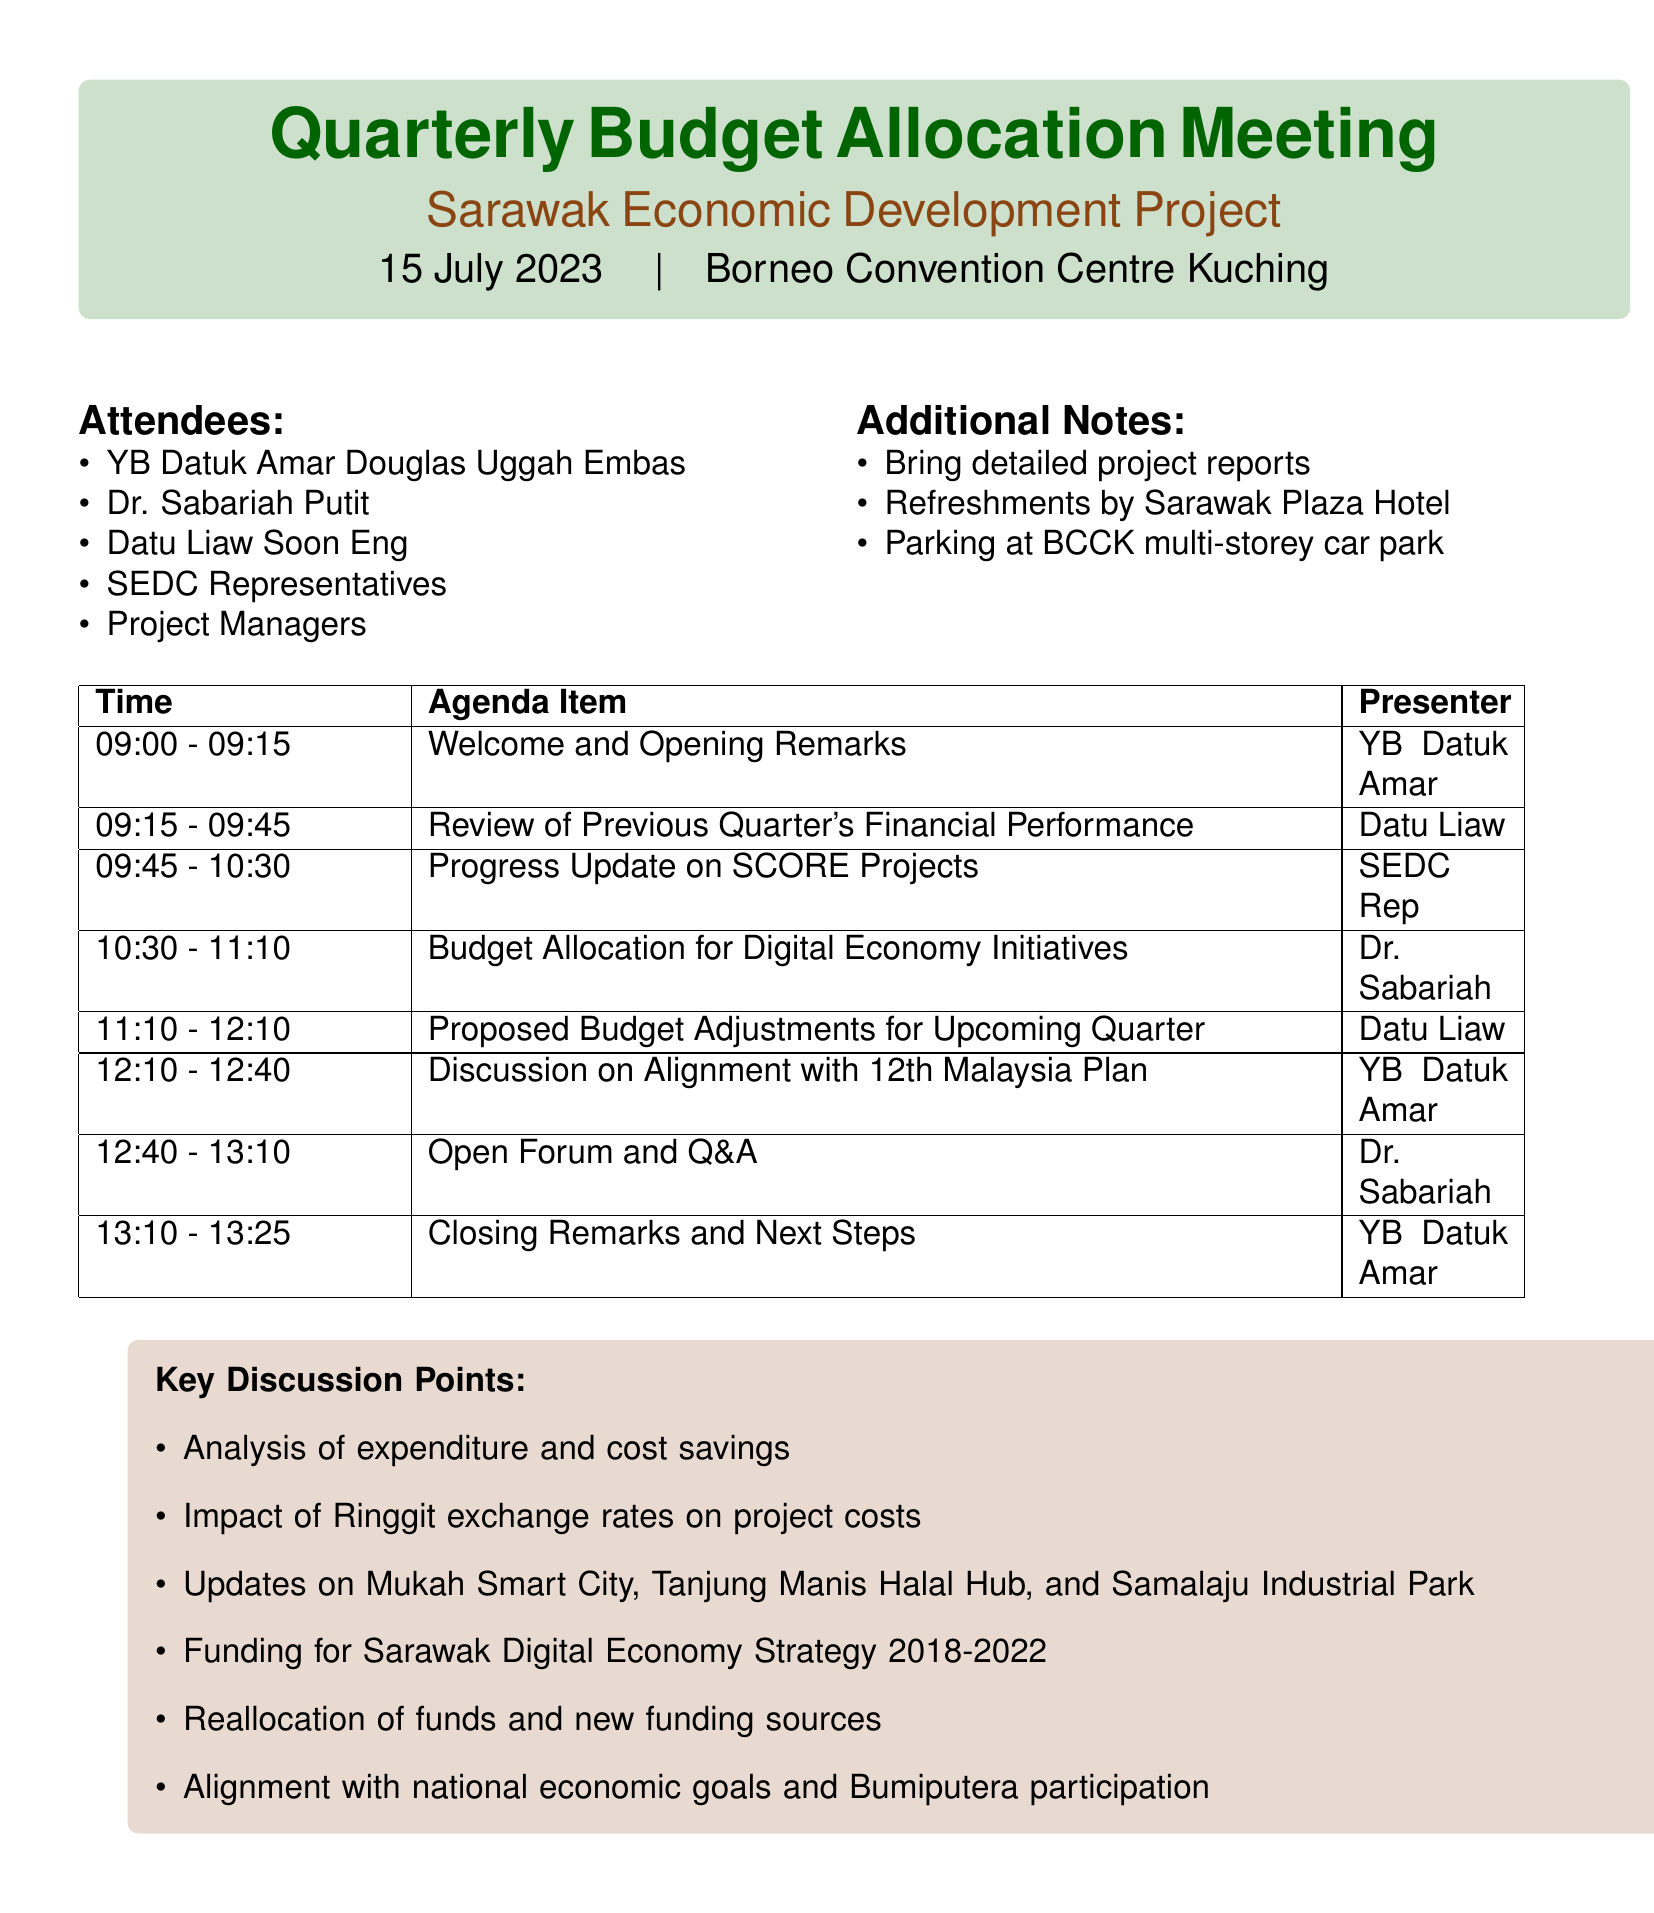What is the meeting date? The meeting date is mentioned in the document as 15 July 2023.
Answer: 15 July 2023 Who is the presenter for the budget allocation item? Dr. Sabariah Putit is listed as the presenter for the Budget Allocation for Digital Economy Initiatives.
Answer: Dr. Sabariah Putit How long is the progress update on SCORE projects scheduled for? The duration for the progress update on SCORE projects is provided in the agenda, which is 45 minutes.
Answer: 45 minutes What is one key point discussed regarding the previous quarter's financial performance? One of the key points mentioned is the analysis of expenditure against allocated budget.
Answer: Analysis of expenditure against allocated budget What is the venue for the meeting? The document specifies the venue as Borneo Convention Centre Kuching.
Answer: Borneo Convention Centre Kuching Which item addresses adjustments for the upcoming quarter? The section titled "Proposed Budget Adjustments for Upcoming Quarter" addresses this subject.
Answer: Proposed Budget Adjustments for Upcoming Quarter How many attendees are listed in the document? The number of attendees can be counted from the list provided, which includes five specific individuals and groups.
Answer: Five Who will facilitate the open forum and Q&A session? Dr. Sabariah Putit is designated as the facilitator for the open forum and Q&A.
Answer: Dr. Sabariah Putit 